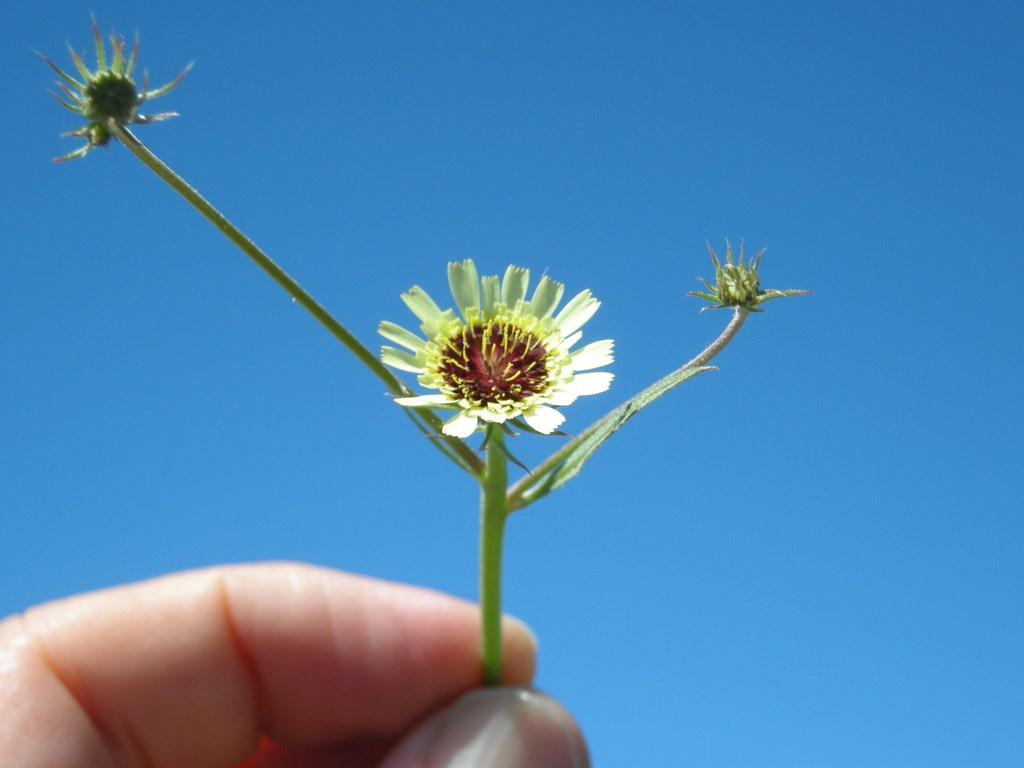Describe this image in one or two sentences. In this image at the bottom I can see person's hand which is holding a stem, on which there are flowers background is in blue. 